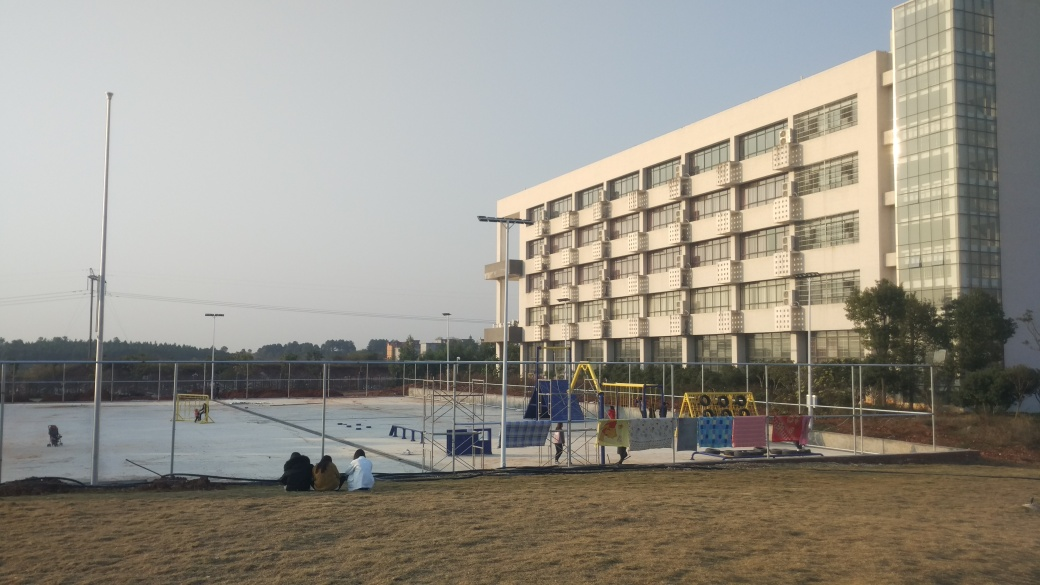Can you tell me about the buildings in the background? The building in the background appears to be a multi-storied structure with a modern architectural style. It has numerous windows that reflect the sunlight, with an adjacent section featuring a glass facade, which could indicate a commercial or educational purpose for the building. 